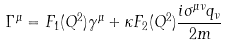Convert formula to latex. <formula><loc_0><loc_0><loc_500><loc_500>\Gamma ^ { \mu } = F _ { 1 } ( Q ^ { 2 } ) \gamma ^ { \mu } + \kappa F _ { 2 } ( Q ^ { 2 } ) \frac { i \sigma ^ { \mu \nu } q _ { \nu } } { 2 m }</formula> 